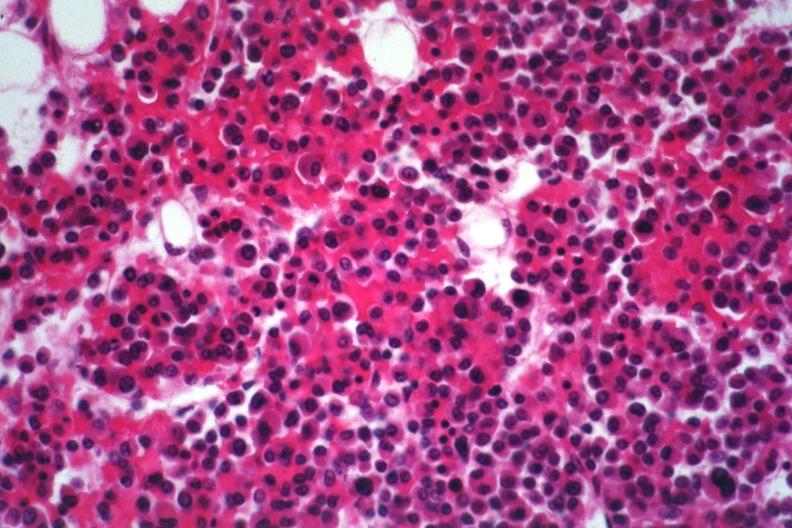s retroperitoneal leiomyosarcoma present?
Answer the question using a single word or phrase. No 